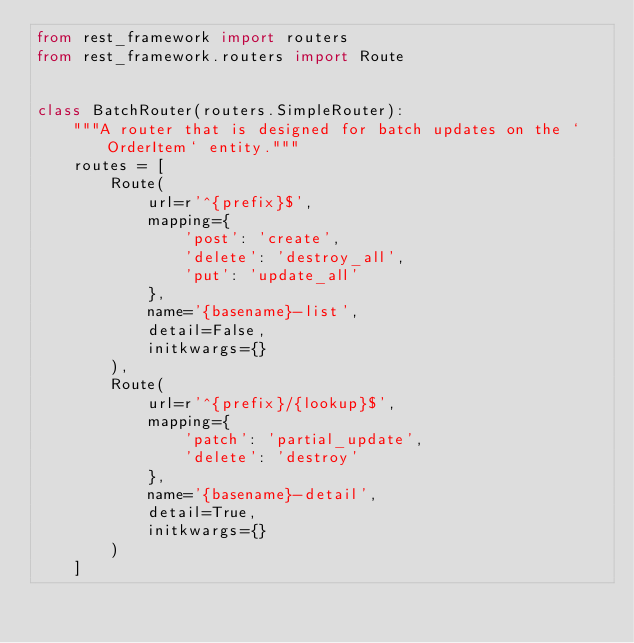<code> <loc_0><loc_0><loc_500><loc_500><_Python_>from rest_framework import routers
from rest_framework.routers import Route


class BatchRouter(routers.SimpleRouter):
    """A router that is designed for batch updates on the `OrderItem` entity."""
    routes = [
        Route(
            url=r'^{prefix}$',
            mapping={
                'post': 'create',
                'delete': 'destroy_all',
                'put': 'update_all'
            },
            name='{basename}-list',
            detail=False,
            initkwargs={}
        ),
        Route(
            url=r'^{prefix}/{lookup}$',
            mapping={
                'patch': 'partial_update',
                'delete': 'destroy'
            },
            name='{basename}-detail',
            detail=True,
            initkwargs={}
        )
    ]
</code> 